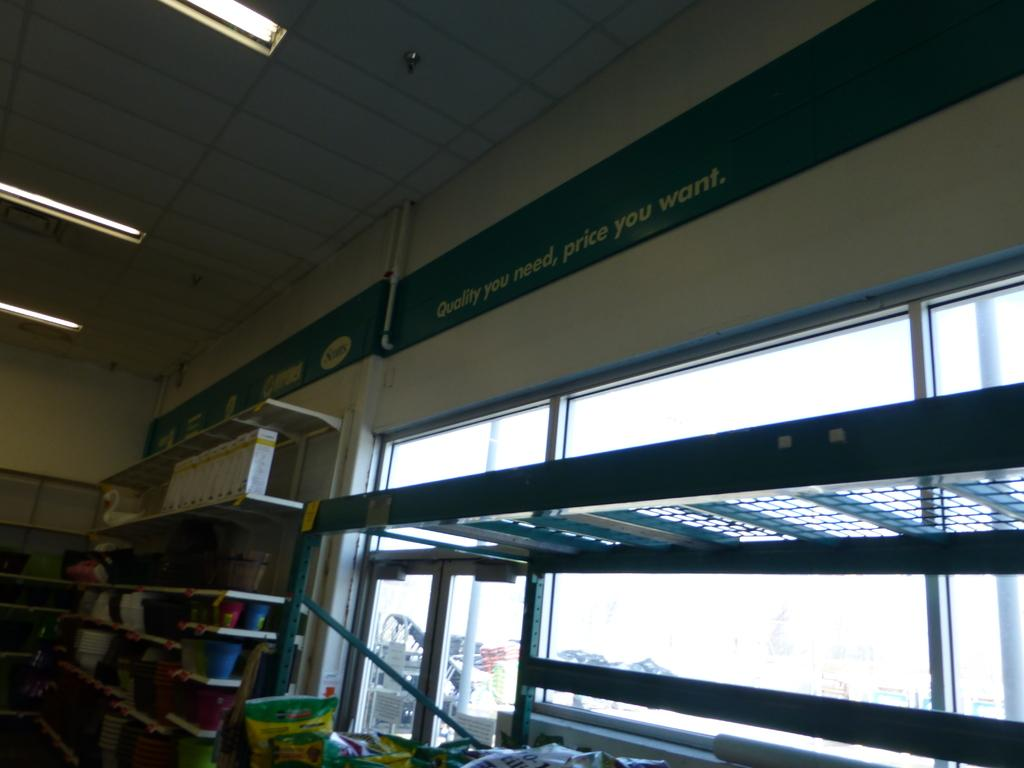<image>
Share a concise interpretation of the image provided. A rather dismal looking room has a sign reading Quality you need along the  top. 